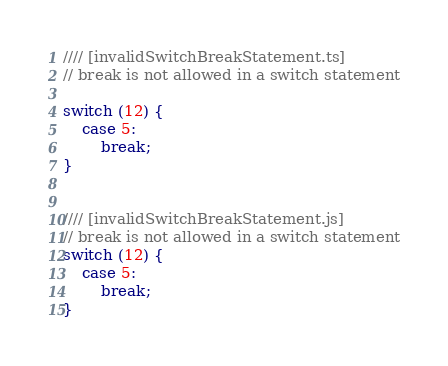Convert code to text. <code><loc_0><loc_0><loc_500><loc_500><_JavaScript_>//// [invalidSwitchBreakStatement.ts]
// break is not allowed in a switch statement

switch (12) {
    case 5:
        break;
}


//// [invalidSwitchBreakStatement.js]
// break is not allowed in a switch statement
switch (12) {
    case 5:
        break;
}
</code> 